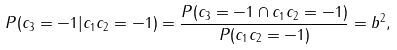<formula> <loc_0><loc_0><loc_500><loc_500>P ( c _ { 3 } = - 1 | c _ { 1 } c _ { 2 } = - 1 ) = \frac { P ( c _ { 3 } = - 1 \cap c _ { 1 } c _ { 2 } = - 1 ) } { P ( c _ { 1 } c _ { 2 } = - 1 ) } = b ^ { 2 } ,</formula> 